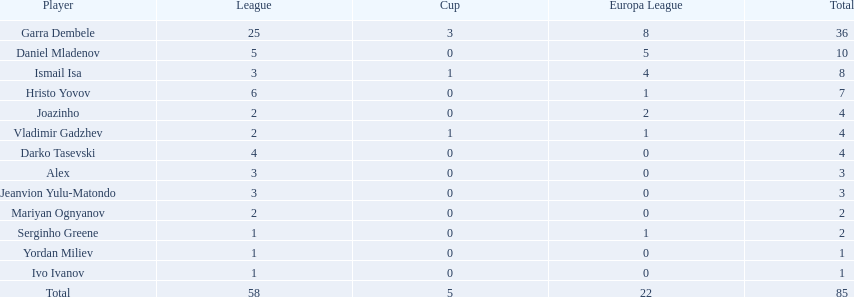Who were the players that didn't score in all three competitions? Daniel Mladenov, Hristo Yovov, Joazinho, Darko Tasevski, Alex, Jeanvion Yulu-Matondo, Mariyan Ognyanov, Serginho Greene, Yordan Miliev, Ivo Ivanov. Out of those, who had a total not exceeding 5? Darko Tasevski, Alex, Jeanvion Yulu-Matondo, Mariyan Ognyanov, Serginho Greene, Yordan Miliev, Ivo Ivanov. Who managed to score more than 1 in total? Darko Tasevski, Alex, Jeanvion Yulu-Matondo, Mariyan Ognyanov. Which player had the least league points? Mariyan Ognyanov. 